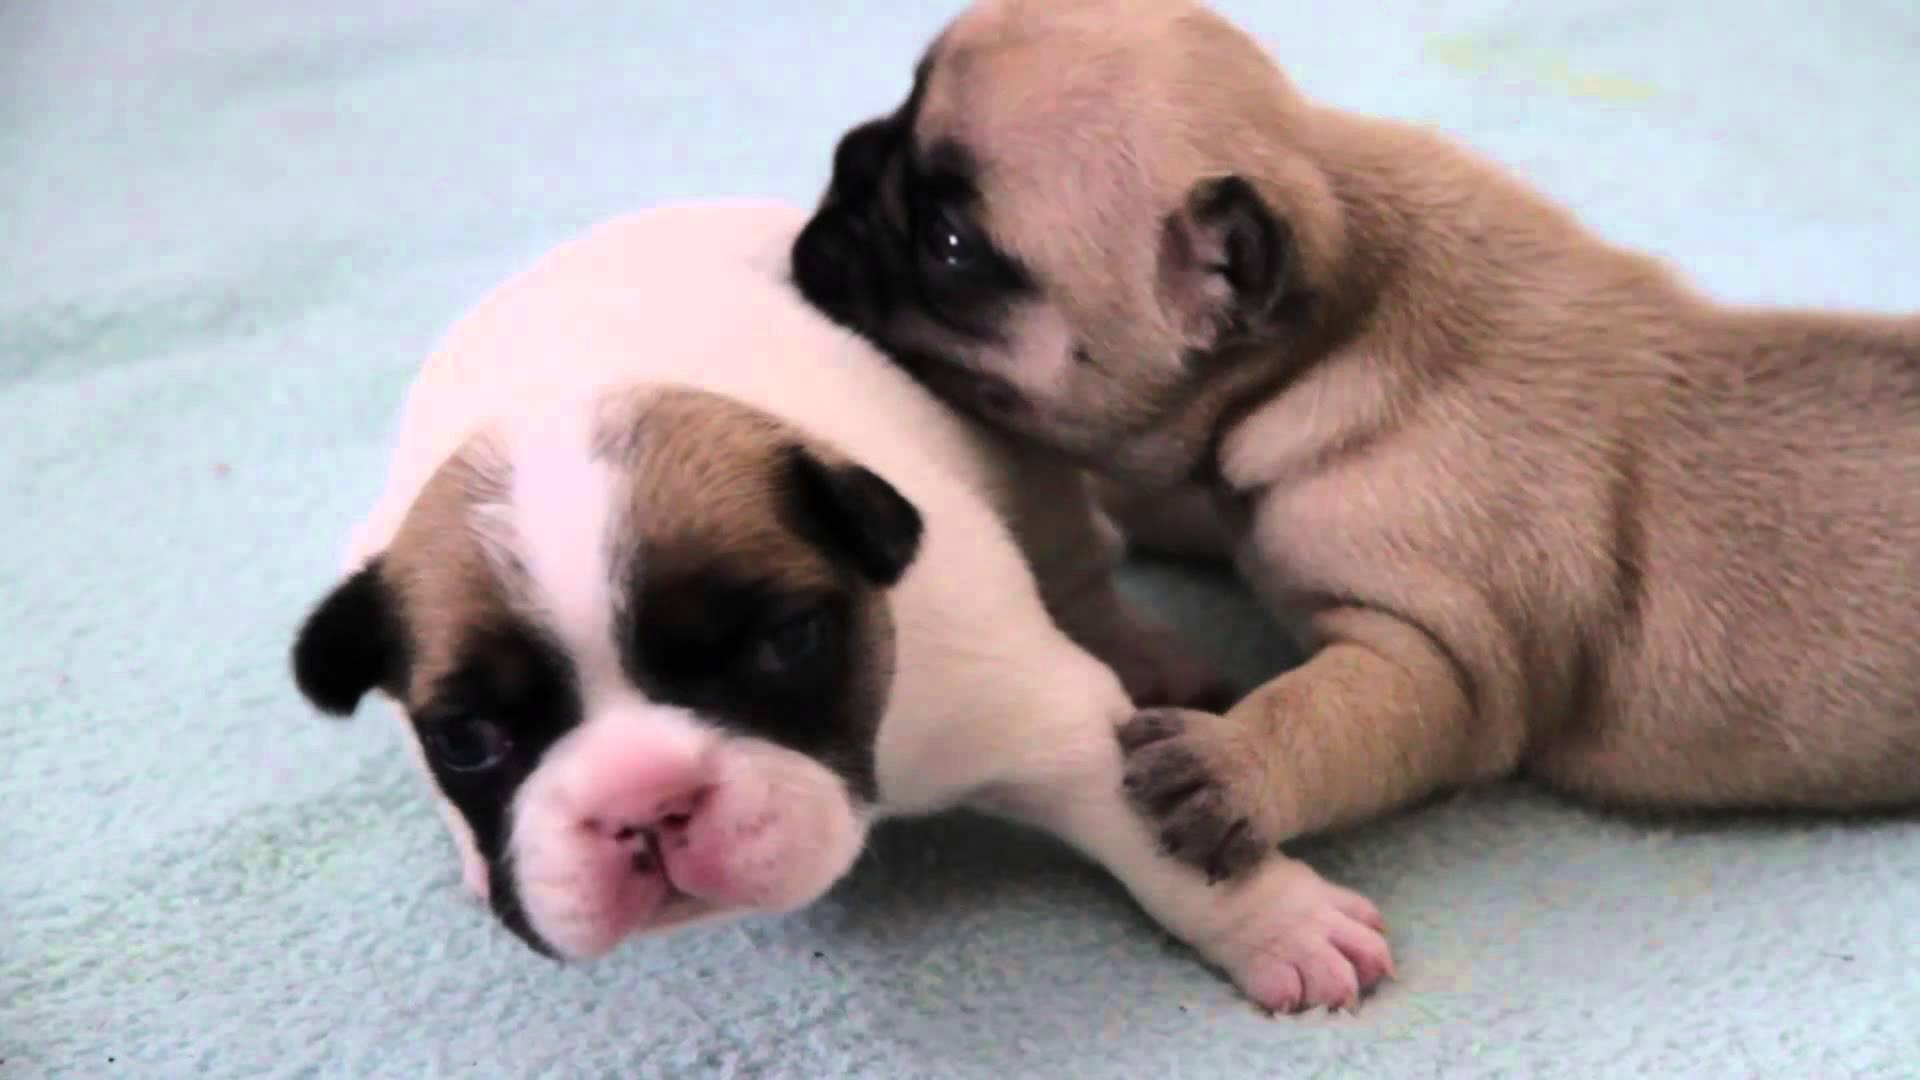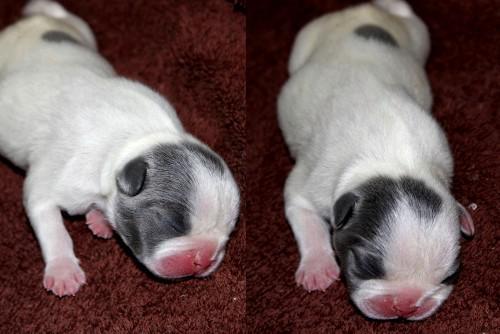The first image is the image on the left, the second image is the image on the right. For the images shown, is this caption "the image pair has no more than 4 puppies" true? Answer yes or no. Yes. The first image is the image on the left, the second image is the image on the right. Considering the images on both sides, is "There is an image with no more and no less than two dogs." valid? Answer yes or no. Yes. 